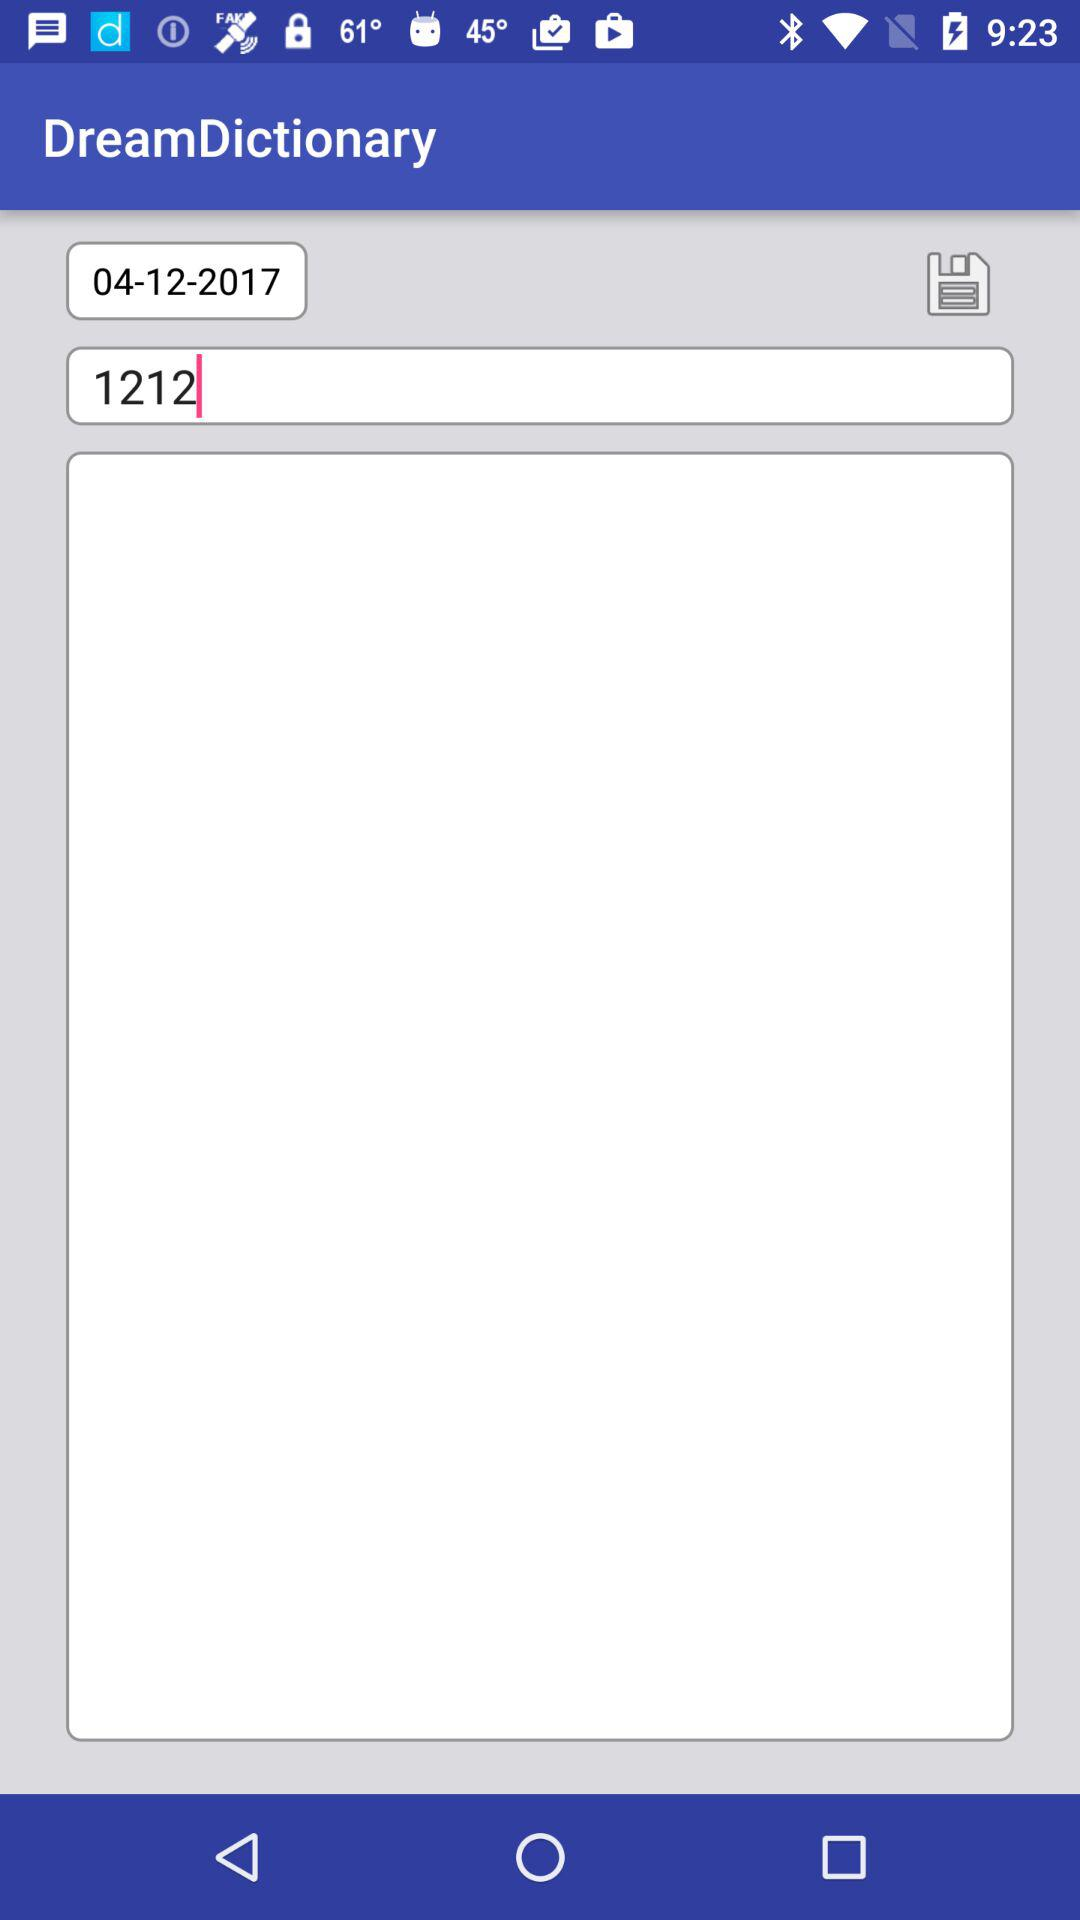What is the date? The date is April 12, 2017. 